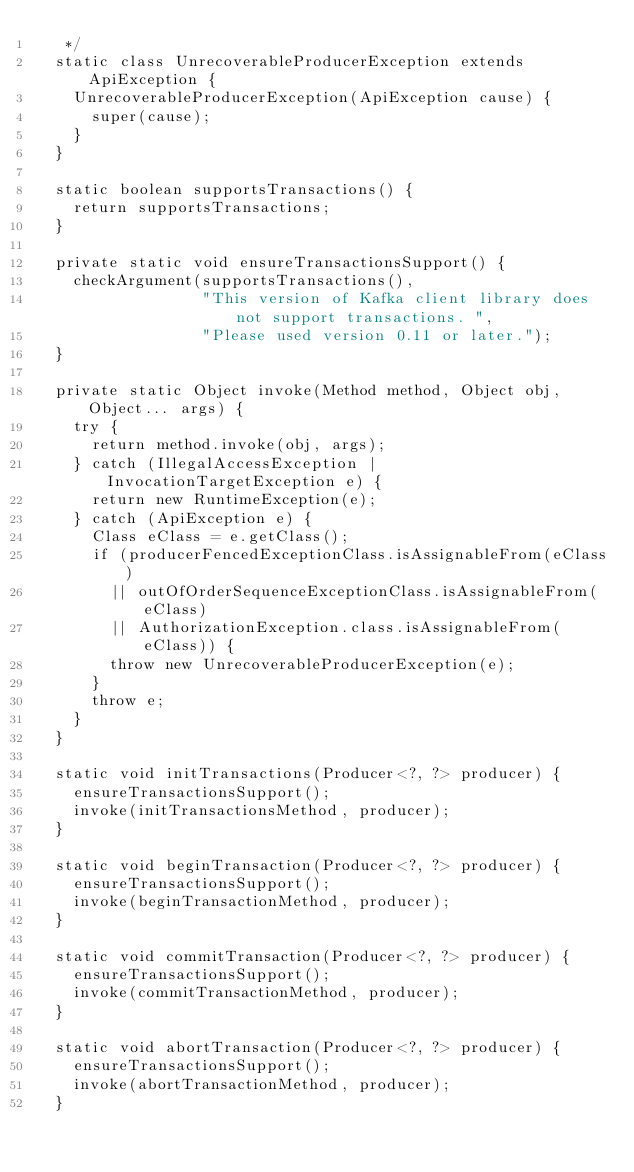Convert code to text. <code><loc_0><loc_0><loc_500><loc_500><_Java_>   */
  static class UnrecoverableProducerException extends ApiException {
    UnrecoverableProducerException(ApiException cause) {
      super(cause);
    }
  }

  static boolean supportsTransactions() {
    return supportsTransactions;
  }

  private static void ensureTransactionsSupport() {
    checkArgument(supportsTransactions(),
                  "This version of Kafka client library does not support transactions. ",
                  "Please used version 0.11 or later.");
  }

  private static Object invoke(Method method, Object obj, Object... args) {
    try {
      return method.invoke(obj, args);
    } catch (IllegalAccessException | InvocationTargetException e) {
      return new RuntimeException(e);
    } catch (ApiException e) {
      Class eClass = e.getClass();
      if (producerFencedExceptionClass.isAssignableFrom(eClass)
        || outOfOrderSequenceExceptionClass.isAssignableFrom(eClass)
        || AuthorizationException.class.isAssignableFrom(eClass)) {
        throw new UnrecoverableProducerException(e);
      }
      throw e;
    }
  }

  static void initTransactions(Producer<?, ?> producer) {
    ensureTransactionsSupport();
    invoke(initTransactionsMethod, producer);
  }

  static void beginTransaction(Producer<?, ?> producer) {
    ensureTransactionsSupport();
    invoke(beginTransactionMethod, producer);
  }

  static void commitTransaction(Producer<?, ?> producer) {
    ensureTransactionsSupport();
    invoke(commitTransactionMethod, producer);
  }

  static void abortTransaction(Producer<?, ?> producer) {
    ensureTransactionsSupport();
    invoke(abortTransactionMethod, producer);
  }
</code> 